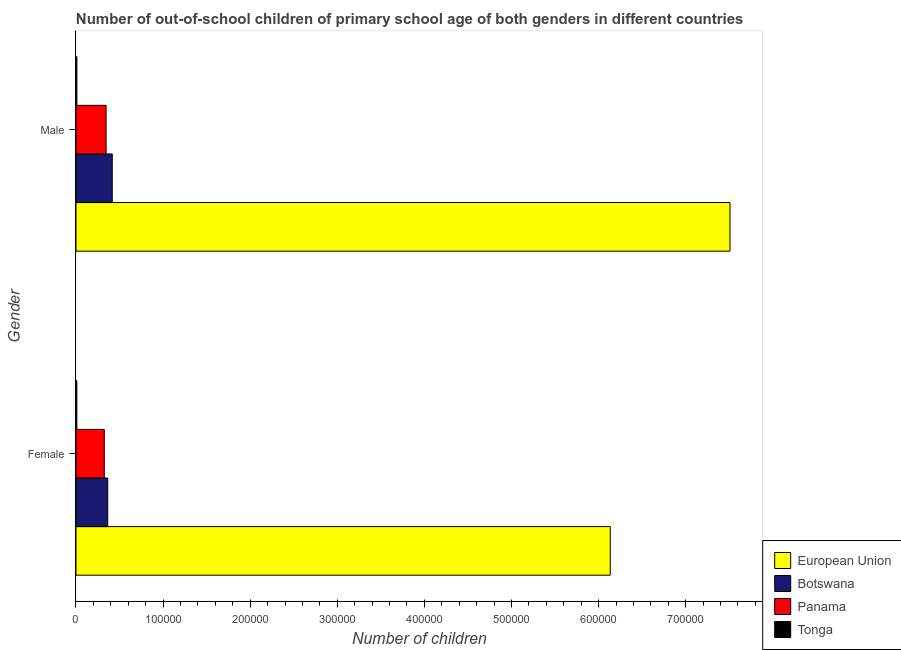How many different coloured bars are there?
Provide a short and direct response. 4. How many groups of bars are there?
Make the answer very short. 2. Are the number of bars on each tick of the Y-axis equal?
Offer a very short reply. Yes. How many bars are there on the 1st tick from the top?
Give a very brief answer. 4. How many bars are there on the 2nd tick from the bottom?
Make the answer very short. 4. What is the number of male out-of-school students in Botswana?
Provide a short and direct response. 4.17e+04. Across all countries, what is the maximum number of female out-of-school students?
Your answer should be very brief. 6.13e+05. Across all countries, what is the minimum number of male out-of-school students?
Provide a succinct answer. 1023. In which country was the number of male out-of-school students minimum?
Your answer should be very brief. Tonga. What is the total number of male out-of-school students in the graph?
Offer a very short reply. 8.28e+05. What is the difference between the number of male out-of-school students in Botswana and that in Tonga?
Provide a short and direct response. 4.06e+04. What is the difference between the number of female out-of-school students in European Union and the number of male out-of-school students in Panama?
Your response must be concise. 5.79e+05. What is the average number of male out-of-school students per country?
Give a very brief answer. 2.07e+05. What is the difference between the number of female out-of-school students and number of male out-of-school students in Tonga?
Make the answer very short. -62. What is the ratio of the number of male out-of-school students in Botswana to that in Panama?
Provide a succinct answer. 1.21. In how many countries, is the number of female out-of-school students greater than the average number of female out-of-school students taken over all countries?
Make the answer very short. 1. What does the 2nd bar from the top in Female represents?
Provide a short and direct response. Panama. What is the difference between two consecutive major ticks on the X-axis?
Offer a very short reply. 1.00e+05. Does the graph contain grids?
Keep it short and to the point. No. How many legend labels are there?
Offer a very short reply. 4. How are the legend labels stacked?
Your response must be concise. Vertical. What is the title of the graph?
Your answer should be very brief. Number of out-of-school children of primary school age of both genders in different countries. Does "Norway" appear as one of the legend labels in the graph?
Provide a succinct answer. No. What is the label or title of the X-axis?
Your answer should be very brief. Number of children. What is the Number of children in European Union in Female?
Your answer should be very brief. 6.13e+05. What is the Number of children in Botswana in Female?
Offer a very short reply. 3.64e+04. What is the Number of children in Panama in Female?
Your response must be concise. 3.25e+04. What is the Number of children in Tonga in Female?
Ensure brevity in your answer.  961. What is the Number of children of European Union in Male?
Your answer should be compact. 7.51e+05. What is the Number of children in Botswana in Male?
Make the answer very short. 4.17e+04. What is the Number of children in Panama in Male?
Make the answer very short. 3.46e+04. What is the Number of children in Tonga in Male?
Your answer should be very brief. 1023. Across all Gender, what is the maximum Number of children in European Union?
Your answer should be very brief. 7.51e+05. Across all Gender, what is the maximum Number of children in Botswana?
Keep it short and to the point. 4.17e+04. Across all Gender, what is the maximum Number of children in Panama?
Give a very brief answer. 3.46e+04. Across all Gender, what is the maximum Number of children of Tonga?
Offer a terse response. 1023. Across all Gender, what is the minimum Number of children of European Union?
Offer a very short reply. 6.13e+05. Across all Gender, what is the minimum Number of children of Botswana?
Your answer should be compact. 3.64e+04. Across all Gender, what is the minimum Number of children in Panama?
Your answer should be compact. 3.25e+04. Across all Gender, what is the minimum Number of children of Tonga?
Make the answer very short. 961. What is the total Number of children in European Union in the graph?
Offer a terse response. 1.36e+06. What is the total Number of children of Botswana in the graph?
Offer a terse response. 7.81e+04. What is the total Number of children in Panama in the graph?
Make the answer very short. 6.71e+04. What is the total Number of children in Tonga in the graph?
Your answer should be very brief. 1984. What is the difference between the Number of children of European Union in Female and that in Male?
Make the answer very short. -1.37e+05. What is the difference between the Number of children in Botswana in Female and that in Male?
Offer a very short reply. -5214. What is the difference between the Number of children of Panama in Female and that in Male?
Your response must be concise. -2050. What is the difference between the Number of children in Tonga in Female and that in Male?
Ensure brevity in your answer.  -62. What is the difference between the Number of children of European Union in Female and the Number of children of Botswana in Male?
Provide a succinct answer. 5.72e+05. What is the difference between the Number of children of European Union in Female and the Number of children of Panama in Male?
Ensure brevity in your answer.  5.79e+05. What is the difference between the Number of children of European Union in Female and the Number of children of Tonga in Male?
Give a very brief answer. 6.12e+05. What is the difference between the Number of children in Botswana in Female and the Number of children in Panama in Male?
Your answer should be very brief. 1880. What is the difference between the Number of children in Botswana in Female and the Number of children in Tonga in Male?
Provide a short and direct response. 3.54e+04. What is the difference between the Number of children in Panama in Female and the Number of children in Tonga in Male?
Provide a short and direct response. 3.15e+04. What is the average Number of children in European Union per Gender?
Make the answer very short. 6.82e+05. What is the average Number of children of Botswana per Gender?
Offer a very short reply. 3.90e+04. What is the average Number of children of Panama per Gender?
Ensure brevity in your answer.  3.35e+04. What is the average Number of children of Tonga per Gender?
Keep it short and to the point. 992. What is the difference between the Number of children of European Union and Number of children of Botswana in Female?
Your answer should be compact. 5.77e+05. What is the difference between the Number of children of European Union and Number of children of Panama in Female?
Provide a short and direct response. 5.81e+05. What is the difference between the Number of children of European Union and Number of children of Tonga in Female?
Your response must be concise. 6.12e+05. What is the difference between the Number of children in Botswana and Number of children in Panama in Female?
Give a very brief answer. 3930. What is the difference between the Number of children in Botswana and Number of children in Tonga in Female?
Give a very brief answer. 3.55e+04. What is the difference between the Number of children of Panama and Number of children of Tonga in Female?
Your answer should be very brief. 3.15e+04. What is the difference between the Number of children of European Union and Number of children of Botswana in Male?
Your answer should be compact. 7.09e+05. What is the difference between the Number of children of European Union and Number of children of Panama in Male?
Your response must be concise. 7.16e+05. What is the difference between the Number of children of European Union and Number of children of Tonga in Male?
Give a very brief answer. 7.50e+05. What is the difference between the Number of children of Botswana and Number of children of Panama in Male?
Provide a short and direct response. 7094. What is the difference between the Number of children in Botswana and Number of children in Tonga in Male?
Your answer should be compact. 4.06e+04. What is the difference between the Number of children in Panama and Number of children in Tonga in Male?
Keep it short and to the point. 3.35e+04. What is the ratio of the Number of children of European Union in Female to that in Male?
Keep it short and to the point. 0.82. What is the ratio of the Number of children in Botswana in Female to that in Male?
Give a very brief answer. 0.87. What is the ratio of the Number of children of Panama in Female to that in Male?
Keep it short and to the point. 0.94. What is the ratio of the Number of children of Tonga in Female to that in Male?
Provide a succinct answer. 0.94. What is the difference between the highest and the second highest Number of children in European Union?
Give a very brief answer. 1.37e+05. What is the difference between the highest and the second highest Number of children in Botswana?
Offer a terse response. 5214. What is the difference between the highest and the second highest Number of children in Panama?
Provide a short and direct response. 2050. What is the difference between the highest and the second highest Number of children in Tonga?
Offer a terse response. 62. What is the difference between the highest and the lowest Number of children of European Union?
Your answer should be compact. 1.37e+05. What is the difference between the highest and the lowest Number of children of Botswana?
Your response must be concise. 5214. What is the difference between the highest and the lowest Number of children in Panama?
Give a very brief answer. 2050. 